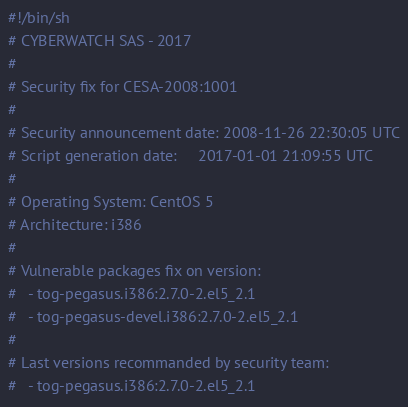<code> <loc_0><loc_0><loc_500><loc_500><_Bash_>#!/bin/sh
# CYBERWATCH SAS - 2017
#
# Security fix for CESA-2008:1001
#
# Security announcement date: 2008-11-26 22:30:05 UTC
# Script generation date:     2017-01-01 21:09:55 UTC
#
# Operating System: CentOS 5
# Architecture: i386
#
# Vulnerable packages fix on version:
#   - tog-pegasus.i386:2.7.0-2.el5_2.1
#   - tog-pegasus-devel.i386:2.7.0-2.el5_2.1
#
# Last versions recommanded by security team:
#   - tog-pegasus.i386:2.7.0-2.el5_2.1</code> 